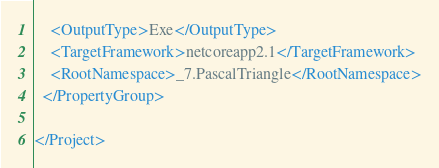Convert code to text. <code><loc_0><loc_0><loc_500><loc_500><_XML_>    <OutputType>Exe</OutputType>
    <TargetFramework>netcoreapp2.1</TargetFramework>
    <RootNamespace>_7.PascalTriangle</RootNamespace>
  </PropertyGroup>

</Project>
</code> 